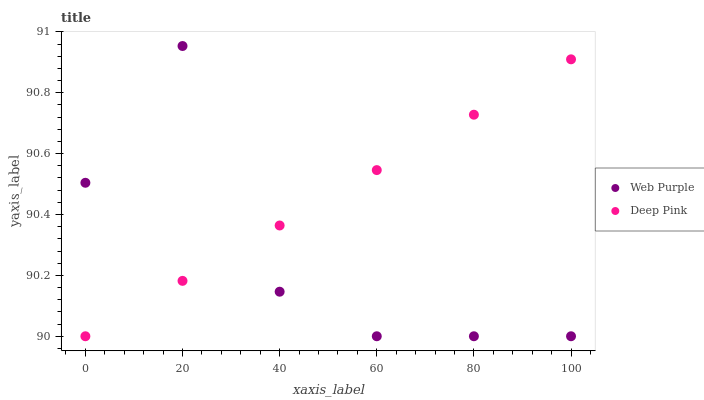Does Web Purple have the minimum area under the curve?
Answer yes or no. Yes. Does Deep Pink have the maximum area under the curve?
Answer yes or no. Yes. Does Deep Pink have the minimum area under the curve?
Answer yes or no. No. Is Deep Pink the smoothest?
Answer yes or no. Yes. Is Web Purple the roughest?
Answer yes or no. Yes. Is Deep Pink the roughest?
Answer yes or no. No. Does Web Purple have the lowest value?
Answer yes or no. Yes. Does Web Purple have the highest value?
Answer yes or no. Yes. Does Deep Pink have the highest value?
Answer yes or no. No. Does Web Purple intersect Deep Pink?
Answer yes or no. Yes. Is Web Purple less than Deep Pink?
Answer yes or no. No. Is Web Purple greater than Deep Pink?
Answer yes or no. No. 